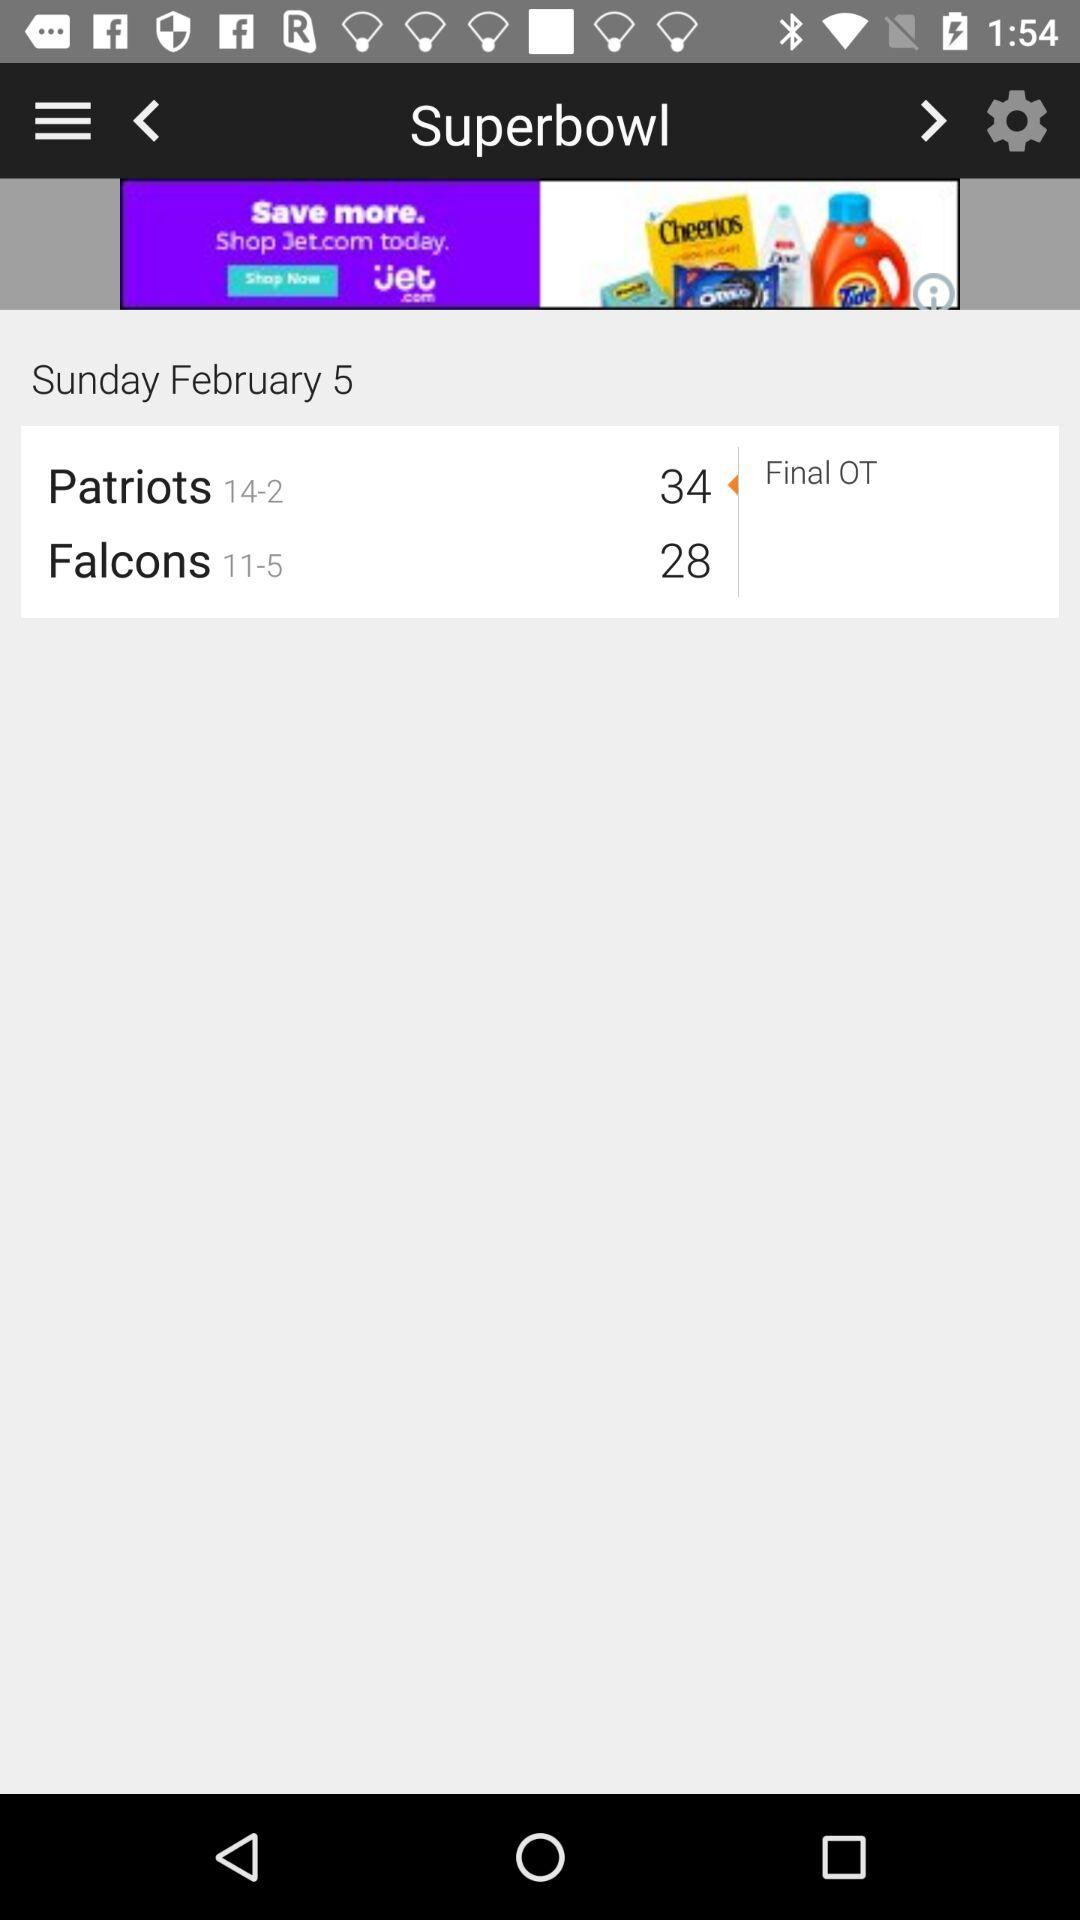What is the date? The date is Sunday, February 5. 